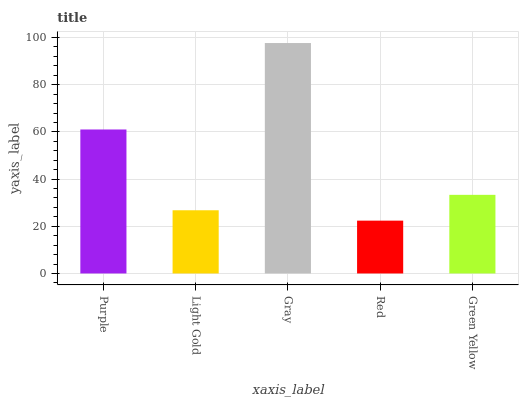Is Red the minimum?
Answer yes or no. Yes. Is Gray the maximum?
Answer yes or no. Yes. Is Light Gold the minimum?
Answer yes or no. No. Is Light Gold the maximum?
Answer yes or no. No. Is Purple greater than Light Gold?
Answer yes or no. Yes. Is Light Gold less than Purple?
Answer yes or no. Yes. Is Light Gold greater than Purple?
Answer yes or no. No. Is Purple less than Light Gold?
Answer yes or no. No. Is Green Yellow the high median?
Answer yes or no. Yes. Is Green Yellow the low median?
Answer yes or no. Yes. Is Gray the high median?
Answer yes or no. No. Is Red the low median?
Answer yes or no. No. 